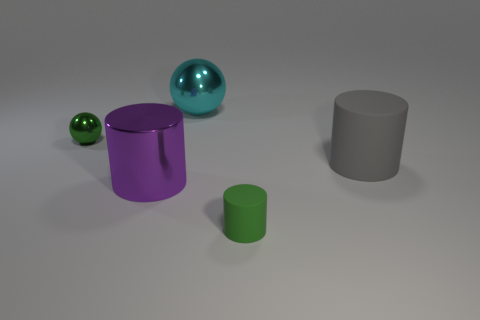There is a green thing that is right of the tiny shiny thing; what number of large gray matte cylinders are in front of it? 0 